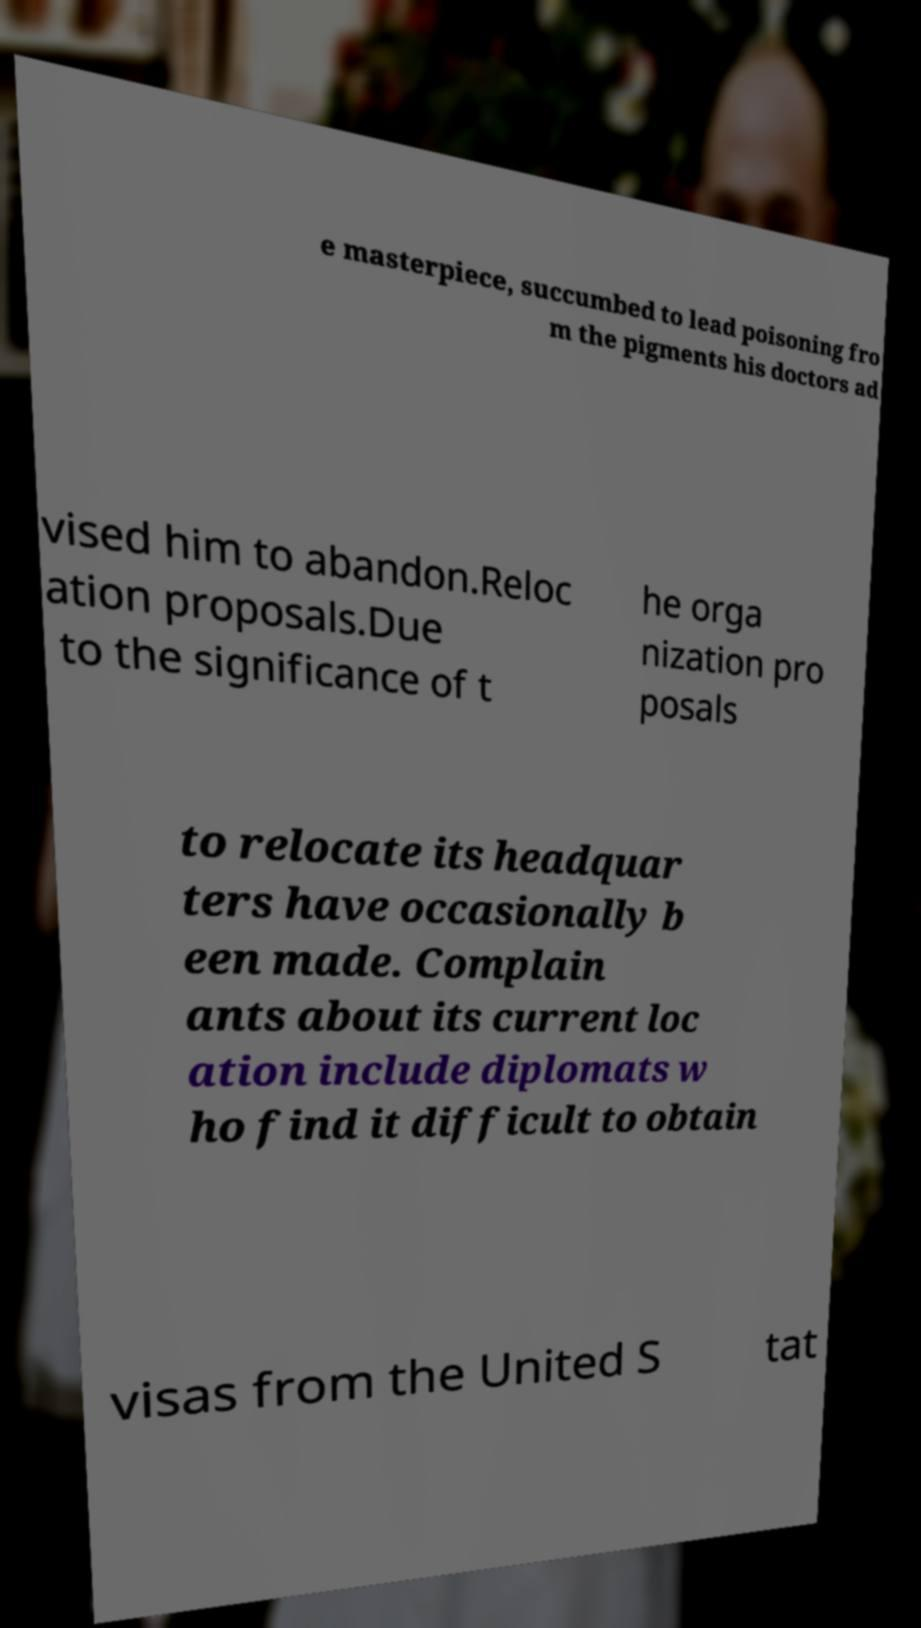There's text embedded in this image that I need extracted. Can you transcribe it verbatim? e masterpiece, succumbed to lead poisoning fro m the pigments his doctors ad vised him to abandon.Reloc ation proposals.Due to the significance of t he orga nization pro posals to relocate its headquar ters have occasionally b een made. Complain ants about its current loc ation include diplomats w ho find it difficult to obtain visas from the United S tat 